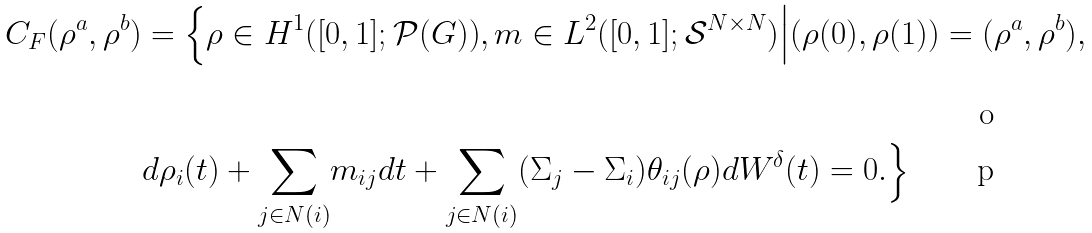<formula> <loc_0><loc_0><loc_500><loc_500>C _ { F } ( \rho ^ { a } , \rho ^ { b } ) & = \Big \{ \rho \in H ^ { 1 } ( [ 0 , 1 ] ; \mathcal { P } ( G ) ) , m \in L ^ { 2 } ( [ 0 , 1 ] ; \mathcal { S } ^ { N \times N } ) \Big | ( \rho ( 0 ) , \rho ( 1 ) ) = ( \rho ^ { a } , \rho ^ { b } ) , \\ & d \rho _ { i } ( t ) + \underset { j \in N ( i ) } { \sum } m _ { i j } d t + \underset { j \in N ( i ) } { \sum } ( \Sigma _ { j } - \Sigma _ { i } ) \theta _ { i j } ( \rho ) d W ^ { \delta } ( t ) = 0 . \Big \}</formula> 